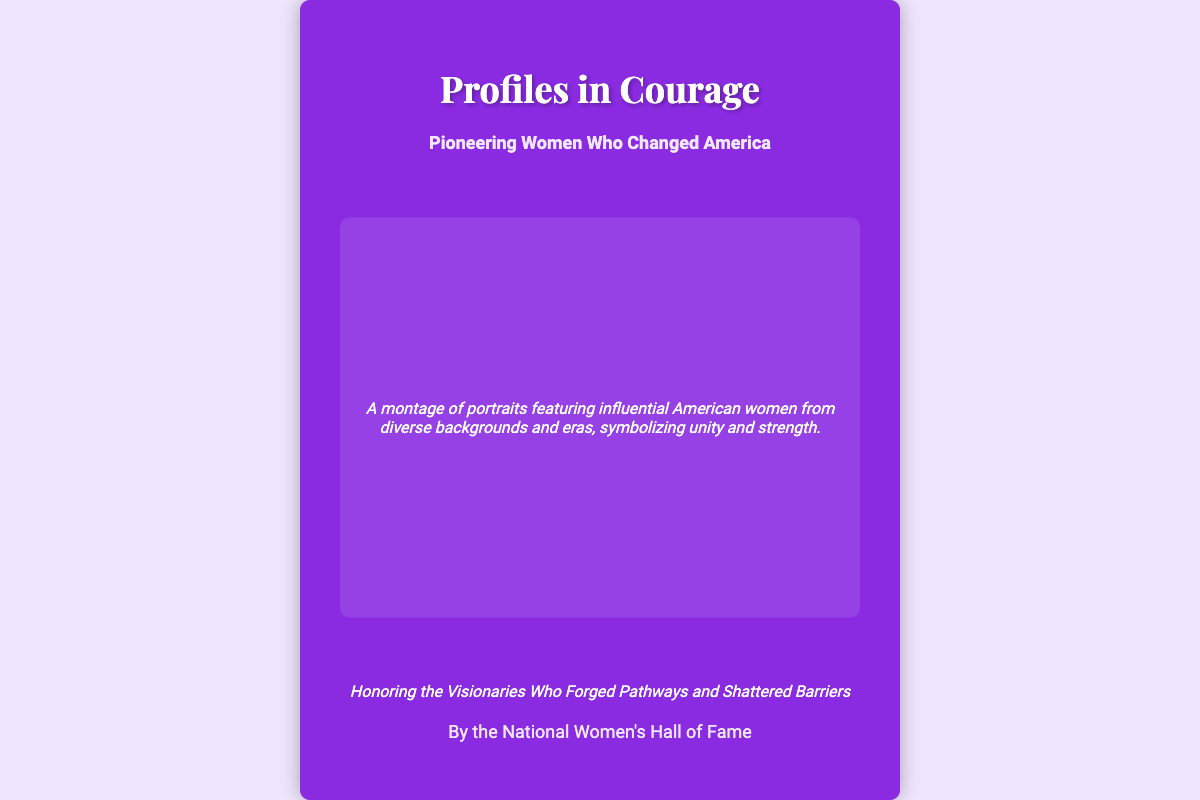what is the title of the book? The title is prominently displayed on the front cover.
Answer: Profiles in Courage who is the author of the book? The author is mentioned below the tagline on the front cover.
Answer: By the National Women's Hall of Fame what is the subtitle of the book? The subtitle is listed right below the title on the front cover.
Answer: Pioneering Women Who Changed America what is the expected release year? The release year is specified in the information section on the back cover.
Answer: 2024 what is the ISBN number? The ISBN is provided in the information section on the back cover.
Answer: 978-1-23456-789-0 what is the address of the publisher? The address is included in the information section on the back cover.
Answer: 76 Fall Street, Seneca Falls, NY 13148, USA what kind of women are featured in the book? The montage description provides insight into the featured women.
Answer: Influential American women from diverse backgrounds and eras what theme does the tagline suggest? The tagline indicates the overarching theme of the book.
Answer: Honoring visionaries and barriers what genres does the book encompass? The blurb hints at the diverse fields represented in the stories.
Answer: Science, literature, civil rights, public service 